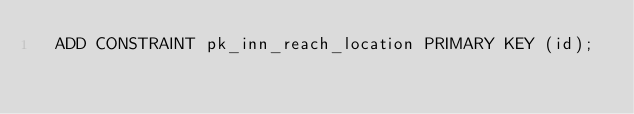Convert code to text. <code><loc_0><loc_0><loc_500><loc_500><_SQL_>  ADD CONSTRAINT pk_inn_reach_location PRIMARY KEY (id);
</code> 